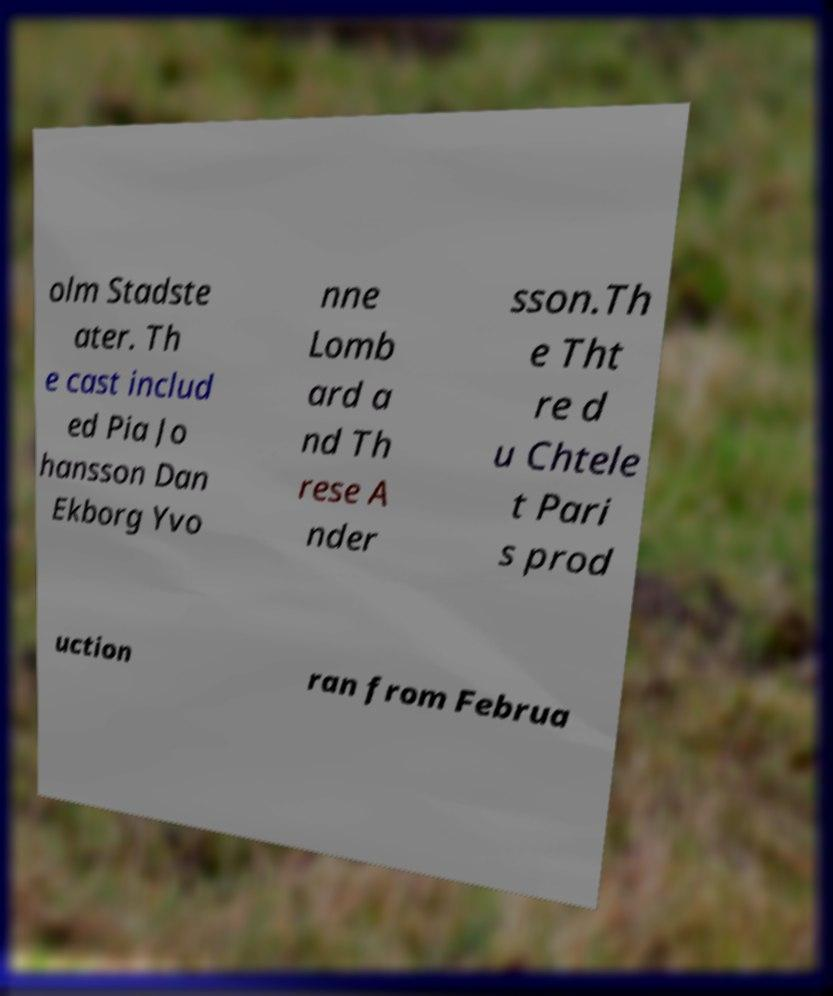There's text embedded in this image that I need extracted. Can you transcribe it verbatim? olm Stadste ater. Th e cast includ ed Pia Jo hansson Dan Ekborg Yvo nne Lomb ard a nd Th rese A nder sson.Th e Tht re d u Chtele t Pari s prod uction ran from Februa 